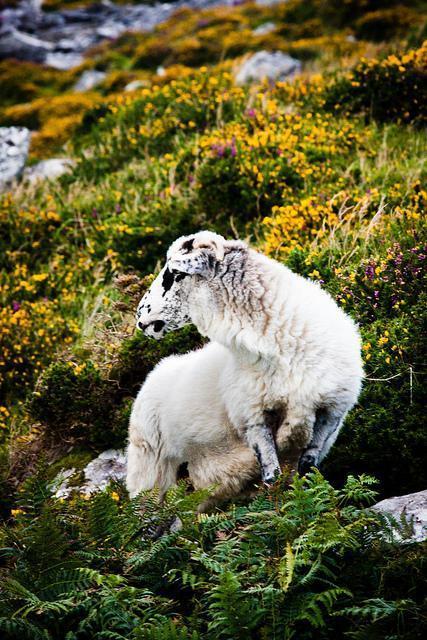How many legs does the animal have?
Give a very brief answer. 4. How many green buses are there in the picture?
Give a very brief answer. 0. 